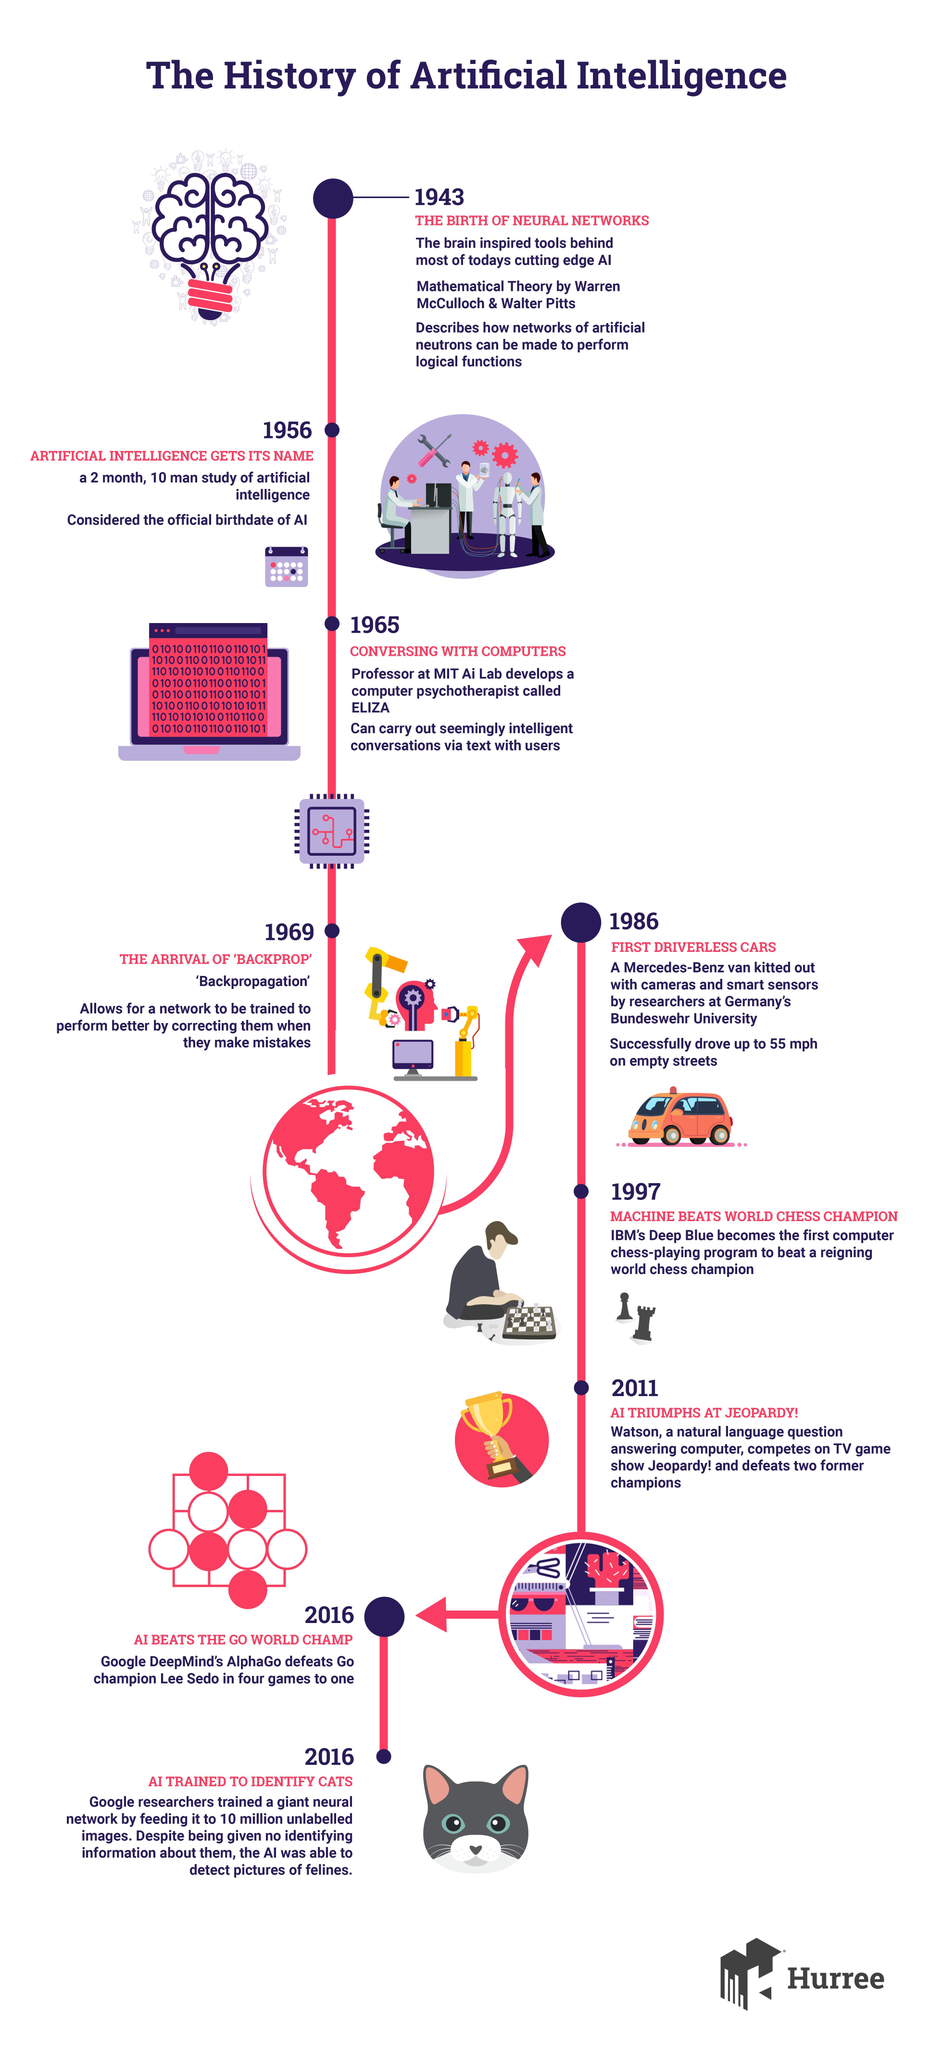Specify some key components in this picture. The game that features a soldier and a king is chess. Mercedes-Benz was the first to introduce driverless cars, marking a significant milestone in the evolution of the automobile industry. The process of improving the performance of a network by adjusting its parameters based on its mistakes is called backpropagation. Thirteen years after the birth of neural networks, artificial intelligence was officially given the name "artificial intelligence. The color of the van is orange, not yellow. 